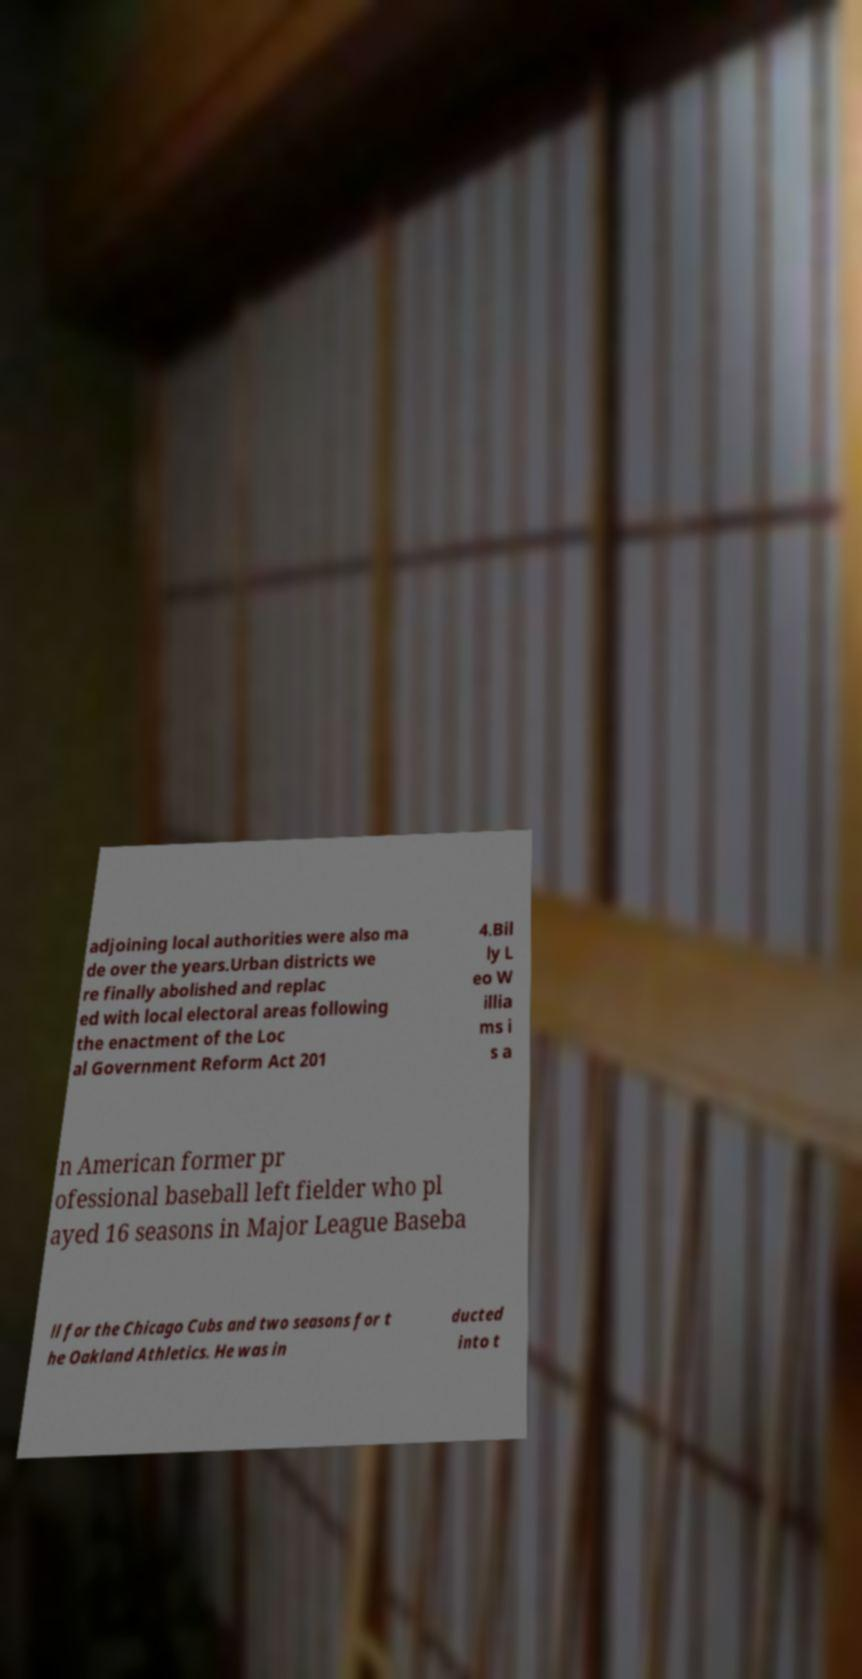Please read and relay the text visible in this image. What does it say? adjoining local authorities were also ma de over the years.Urban districts we re finally abolished and replac ed with local electoral areas following the enactment of the Loc al Government Reform Act 201 4.Bil ly L eo W illia ms i s a n American former pr ofessional baseball left fielder who pl ayed 16 seasons in Major League Baseba ll for the Chicago Cubs and two seasons for t he Oakland Athletics. He was in ducted into t 